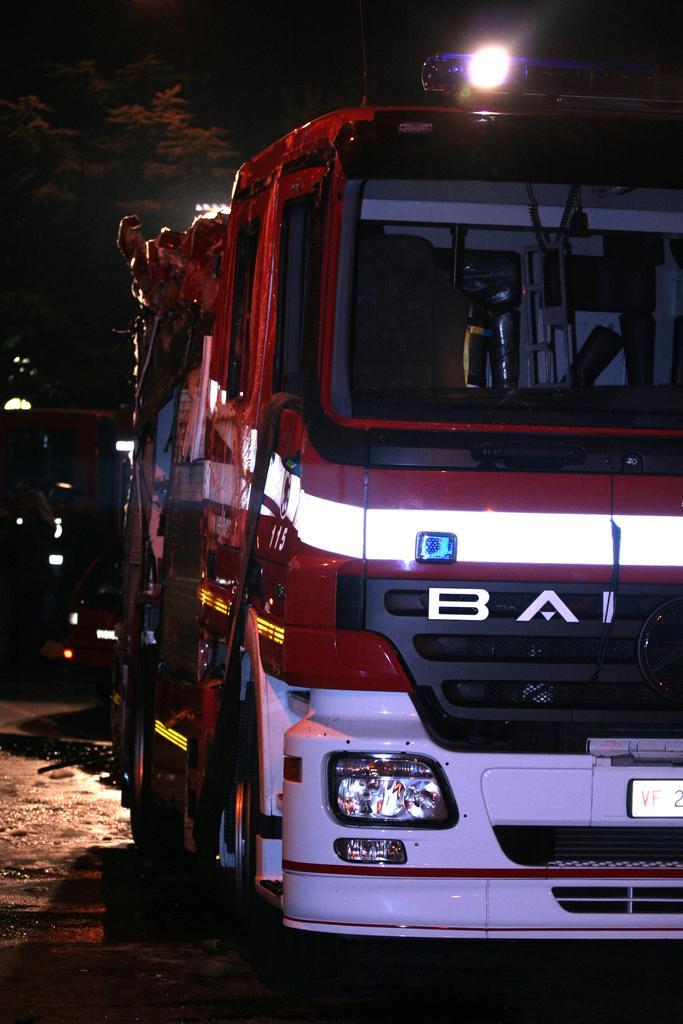In one or two sentences, can you explain what this image depicts? In this image in the foreground there is one vehicle and in the background there are some trees, lights. At the bottom there is a walkway. 